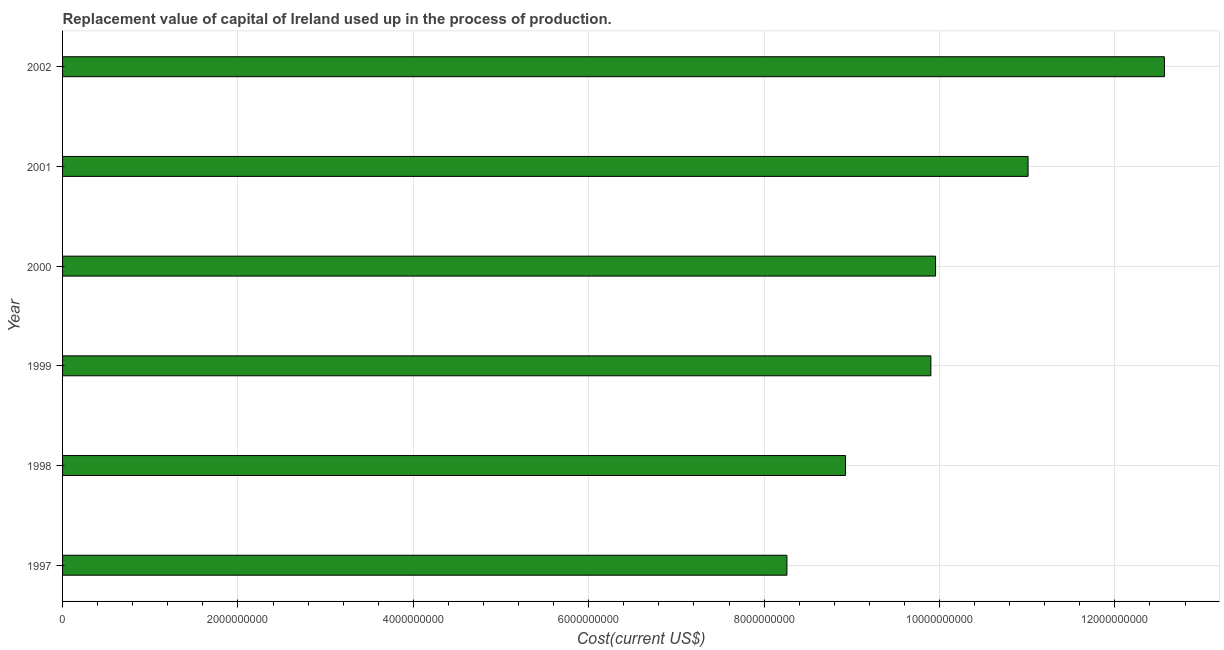Does the graph contain any zero values?
Ensure brevity in your answer.  No. What is the title of the graph?
Provide a short and direct response. Replacement value of capital of Ireland used up in the process of production. What is the label or title of the X-axis?
Keep it short and to the point. Cost(current US$). What is the label or title of the Y-axis?
Provide a short and direct response. Year. What is the consumption of fixed capital in 1999?
Ensure brevity in your answer.  9.90e+09. Across all years, what is the maximum consumption of fixed capital?
Provide a short and direct response. 1.26e+1. Across all years, what is the minimum consumption of fixed capital?
Provide a succinct answer. 8.26e+09. What is the sum of the consumption of fixed capital?
Provide a succinct answer. 6.06e+1. What is the difference between the consumption of fixed capital in 2000 and 2002?
Your answer should be very brief. -2.61e+09. What is the average consumption of fixed capital per year?
Keep it short and to the point. 1.01e+1. What is the median consumption of fixed capital?
Offer a terse response. 9.93e+09. Do a majority of the years between 2001 and 1997 (inclusive) have consumption of fixed capital greater than 8400000000 US$?
Your answer should be compact. Yes. What is the ratio of the consumption of fixed capital in 1998 to that in 1999?
Provide a short and direct response. 0.9. Is the consumption of fixed capital in 1998 less than that in 2002?
Offer a very short reply. Yes. What is the difference between the highest and the second highest consumption of fixed capital?
Make the answer very short. 1.55e+09. Is the sum of the consumption of fixed capital in 1997 and 1998 greater than the maximum consumption of fixed capital across all years?
Offer a terse response. Yes. What is the difference between the highest and the lowest consumption of fixed capital?
Offer a very short reply. 4.30e+09. In how many years, is the consumption of fixed capital greater than the average consumption of fixed capital taken over all years?
Ensure brevity in your answer.  2. What is the difference between two consecutive major ticks on the X-axis?
Offer a terse response. 2.00e+09. What is the Cost(current US$) of 1997?
Your answer should be very brief. 8.26e+09. What is the Cost(current US$) in 1998?
Offer a terse response. 8.93e+09. What is the Cost(current US$) of 1999?
Give a very brief answer. 9.90e+09. What is the Cost(current US$) of 2000?
Keep it short and to the point. 9.96e+09. What is the Cost(current US$) of 2001?
Make the answer very short. 1.10e+1. What is the Cost(current US$) of 2002?
Provide a short and direct response. 1.26e+1. What is the difference between the Cost(current US$) in 1997 and 1998?
Provide a short and direct response. -6.68e+08. What is the difference between the Cost(current US$) in 1997 and 1999?
Your answer should be compact. -1.64e+09. What is the difference between the Cost(current US$) in 1997 and 2000?
Offer a very short reply. -1.69e+09. What is the difference between the Cost(current US$) in 1997 and 2001?
Your response must be concise. -2.75e+09. What is the difference between the Cost(current US$) in 1997 and 2002?
Make the answer very short. -4.30e+09. What is the difference between the Cost(current US$) in 1998 and 1999?
Make the answer very short. -9.73e+08. What is the difference between the Cost(current US$) in 1998 and 2000?
Provide a short and direct response. -1.03e+09. What is the difference between the Cost(current US$) in 1998 and 2001?
Make the answer very short. -2.08e+09. What is the difference between the Cost(current US$) in 1998 and 2002?
Your answer should be very brief. -3.64e+09. What is the difference between the Cost(current US$) in 1999 and 2000?
Provide a succinct answer. -5.37e+07. What is the difference between the Cost(current US$) in 1999 and 2001?
Offer a very short reply. -1.11e+09. What is the difference between the Cost(current US$) in 1999 and 2002?
Your response must be concise. -2.66e+09. What is the difference between the Cost(current US$) in 2000 and 2001?
Give a very brief answer. -1.05e+09. What is the difference between the Cost(current US$) in 2000 and 2002?
Offer a terse response. -2.61e+09. What is the difference between the Cost(current US$) in 2001 and 2002?
Keep it short and to the point. -1.55e+09. What is the ratio of the Cost(current US$) in 1997 to that in 1998?
Keep it short and to the point. 0.93. What is the ratio of the Cost(current US$) in 1997 to that in 1999?
Give a very brief answer. 0.83. What is the ratio of the Cost(current US$) in 1997 to that in 2000?
Give a very brief answer. 0.83. What is the ratio of the Cost(current US$) in 1997 to that in 2002?
Offer a terse response. 0.66. What is the ratio of the Cost(current US$) in 1998 to that in 1999?
Provide a succinct answer. 0.9. What is the ratio of the Cost(current US$) in 1998 to that in 2000?
Your response must be concise. 0.9. What is the ratio of the Cost(current US$) in 1998 to that in 2001?
Offer a very short reply. 0.81. What is the ratio of the Cost(current US$) in 1998 to that in 2002?
Provide a succinct answer. 0.71. What is the ratio of the Cost(current US$) in 1999 to that in 2000?
Make the answer very short. 0.99. What is the ratio of the Cost(current US$) in 1999 to that in 2001?
Your answer should be compact. 0.9. What is the ratio of the Cost(current US$) in 1999 to that in 2002?
Your answer should be very brief. 0.79. What is the ratio of the Cost(current US$) in 2000 to that in 2001?
Make the answer very short. 0.9. What is the ratio of the Cost(current US$) in 2000 to that in 2002?
Provide a succinct answer. 0.79. What is the ratio of the Cost(current US$) in 2001 to that in 2002?
Your answer should be very brief. 0.88. 